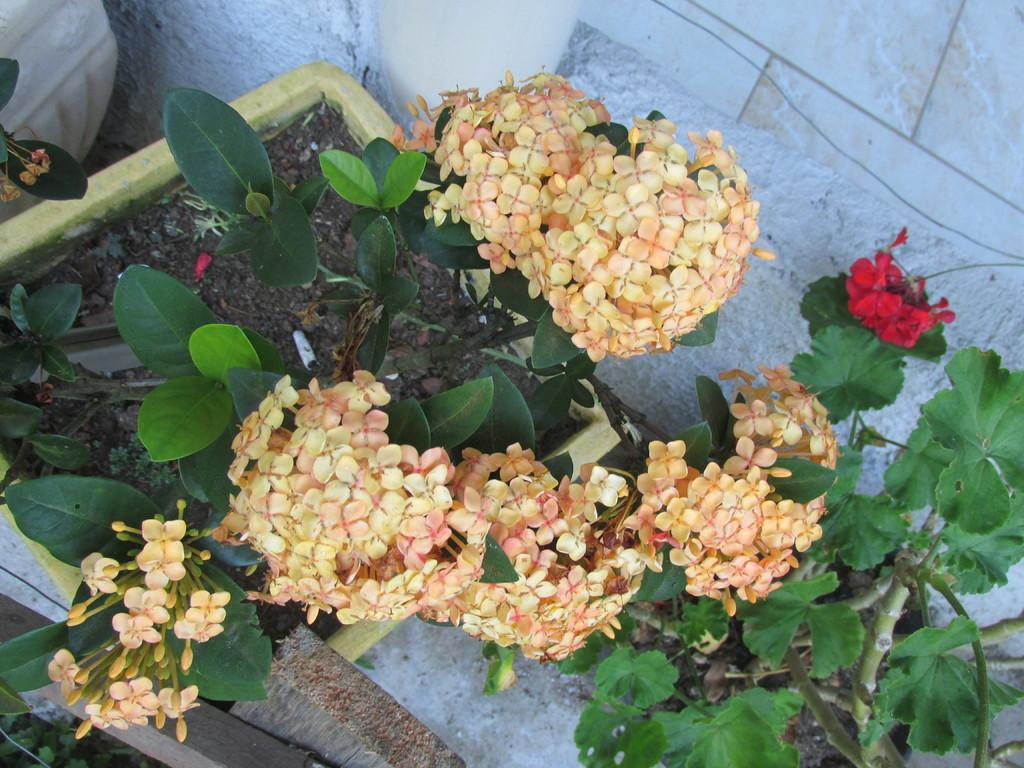What type of vegetation is present in the image? There are trees with flowers in the image. Where are the trees located in the image? The trees are in the middle of the image. What can be seen in the background of the image? There is a wall in the background of the image. How does the fog affect the visibility of the trees in the image? There is no fog present in the image, so it does not affect the visibility of the trees. 